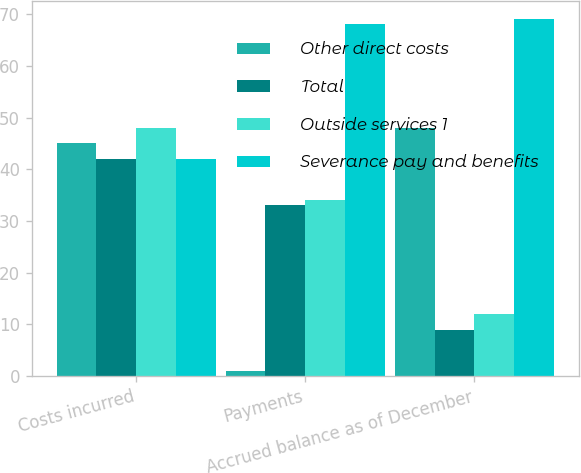<chart> <loc_0><loc_0><loc_500><loc_500><stacked_bar_chart><ecel><fcel>Costs incurred<fcel>Payments<fcel>Accrued balance as of December<nl><fcel>Other direct costs<fcel>45<fcel>1<fcel>48<nl><fcel>Total<fcel>42<fcel>33<fcel>9<nl><fcel>Outside services 1<fcel>48<fcel>34<fcel>12<nl><fcel>Severance pay and benefits<fcel>42<fcel>68<fcel>69<nl></chart> 